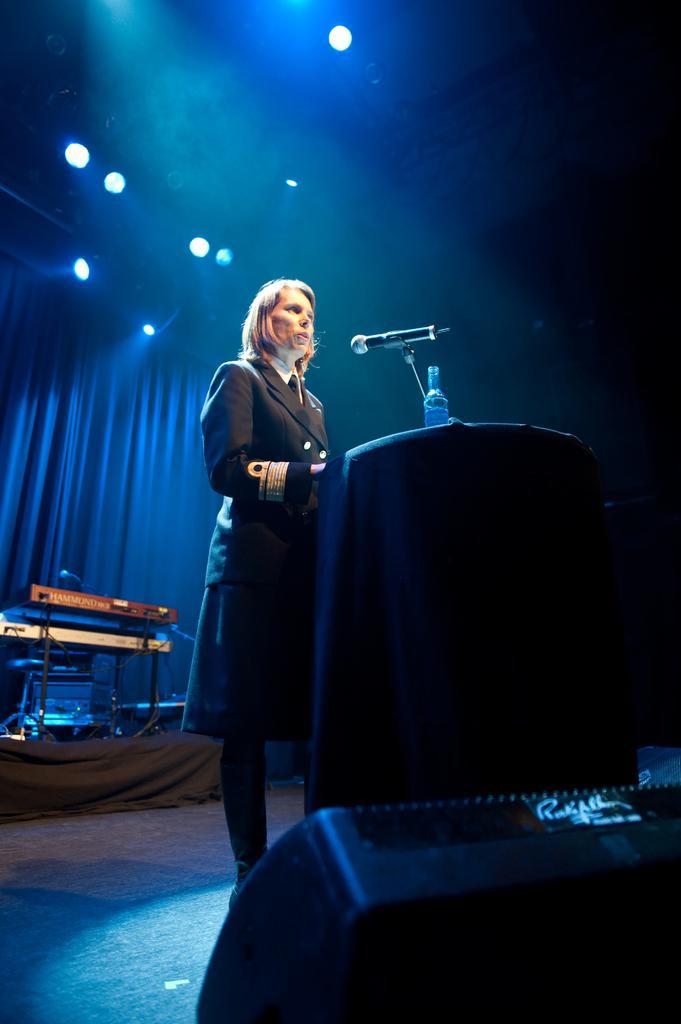Could you give a brief overview of what you see in this image? In this image we can see a lady standing. Near to her there is a stand with a mic and bottle. At the bottom there is a speaker. In the back there is a musical instrument. In the background there is curtain. At the top there are lights. 